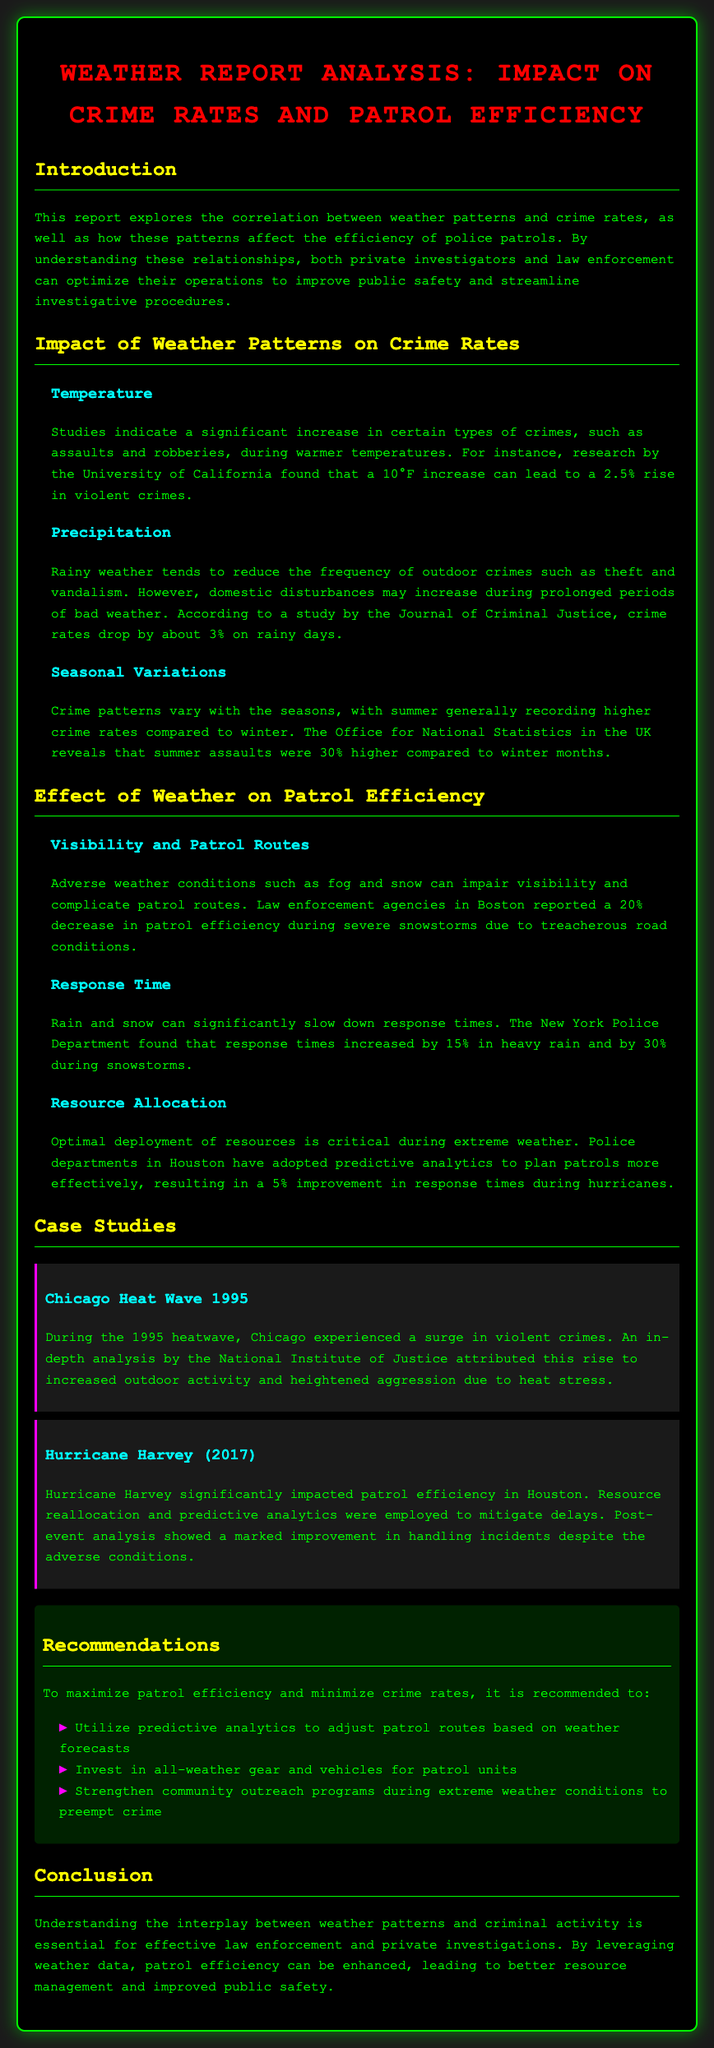What temperature increase leads to a rise in violent crimes? A 10°F increase can lead to a 2.5% rise in violent crimes.
Answer: 10°F What percentage drop in crime rates occurs on rainy days? Crime rates drop by about 3% on rainy days.
Answer: 3% How much did patrol efficiency decrease during severe snowstorms in Boston? Boston reported a 20% decrease in patrol efficiency during severe snowstorms.
Answer: 20% What is the increase in response time during snowstorms according to the New York Police Department? The New York Police Department found that response times increased by 30% during snowstorms.
Answer: 30% What was the increase in summer assaults compared to winter months according to the Office for National Statistics? Summer assaults were 30% higher compared to winter months.
Answer: 30% What year did the Chicago heat wave occur, associated with a surge in violent crimes? The Chicago heat wave occurred in 1995.
Answer: 1995 Which hurricane significantly impacted patrol efficiency in Houston? Hurricane Harvey significantly impacted patrol efficiency in Houston.
Answer: Hurricane Harvey What is one of the recommendations for improving patrol efficiency during extreme weather? Utilize predictive analytics to adjust patrol routes based on weather forecasts.
Answer: Predictive analytics What color represents the section headings in the document? The section headings are colored yellow.
Answer: Yellow 